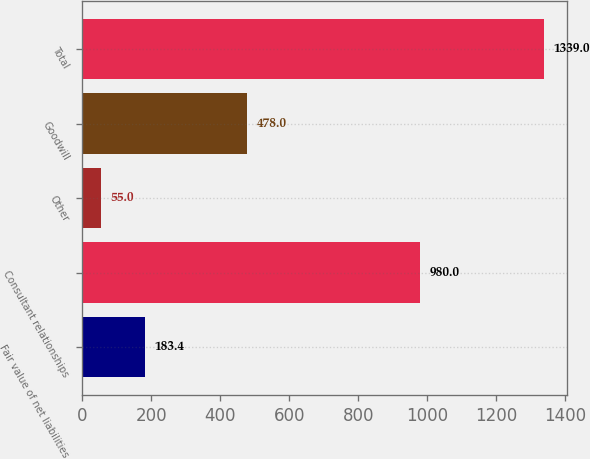<chart> <loc_0><loc_0><loc_500><loc_500><bar_chart><fcel>Fair value of net liabilities<fcel>Consultant relationships<fcel>Other<fcel>Goodwill<fcel>Total<nl><fcel>183.4<fcel>980<fcel>55<fcel>478<fcel>1339<nl></chart> 